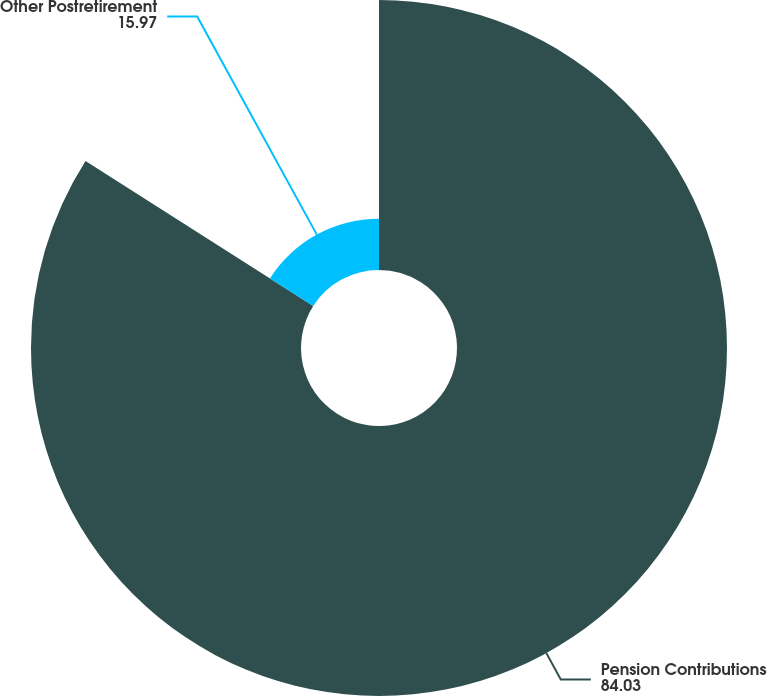<chart> <loc_0><loc_0><loc_500><loc_500><pie_chart><fcel>Pension Contributions<fcel>Other Postretirement<nl><fcel>84.03%<fcel>15.97%<nl></chart> 